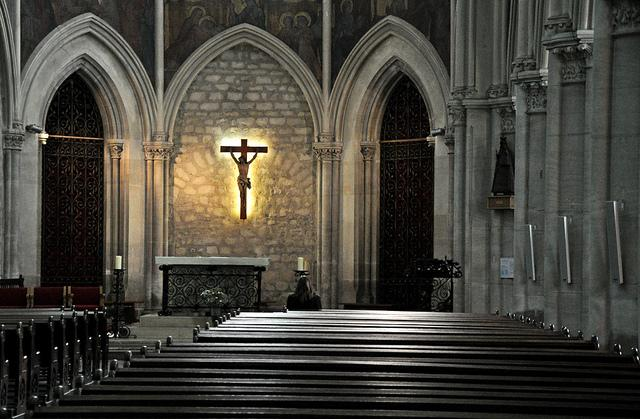What is she doing? praying 